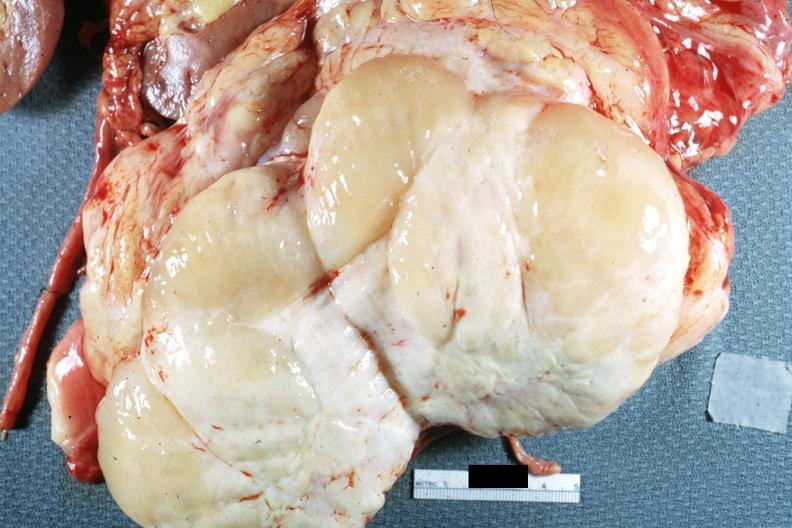what is present?
Answer the question using a single word or phrase. Peritoneum 